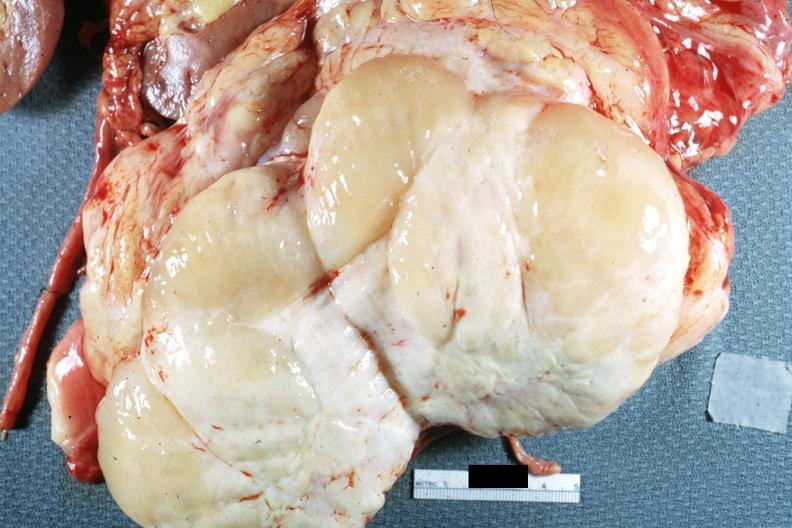what is present?
Answer the question using a single word or phrase. Peritoneum 